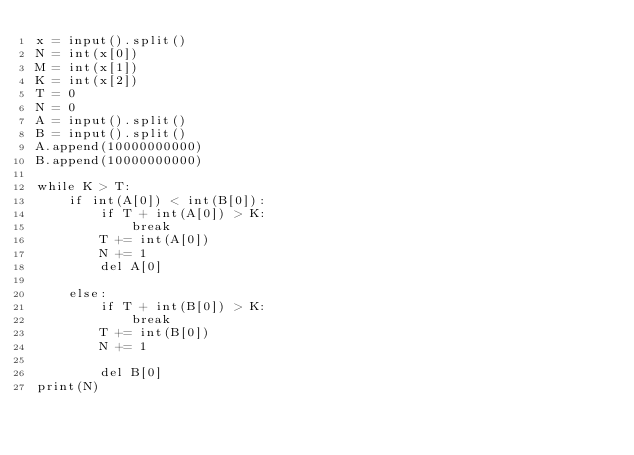<code> <loc_0><loc_0><loc_500><loc_500><_Python_>x = input().split()
N = int(x[0])
M = int(x[1])
K = int(x[2])
T = 0
N = 0
A = input().split()
B = input().split()
A.append(10000000000)
B.append(10000000000)

while K > T:
    if int(A[0]) < int(B[0]):
        if T + int(A[0]) > K:
            break
        T += int(A[0])
        N += 1
        del A[0]

    else:
        if T + int(B[0]) > K:
            break
        T += int(B[0])
        N += 1

        del B[0]
print(N)</code> 